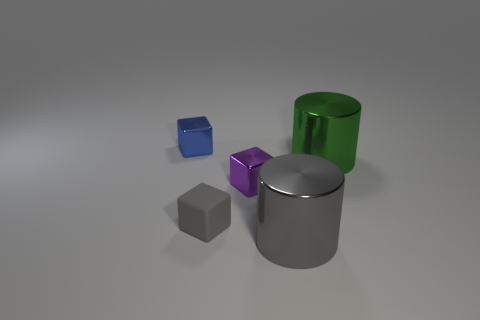Do the large metal thing in front of the small gray matte cube and the small block that is in front of the purple thing have the same color?
Offer a very short reply. Yes. There is another big object that is the same color as the matte thing; what shape is it?
Keep it short and to the point. Cylinder. There is a object that is behind the purple metal block and to the right of the blue shiny cube; what is its shape?
Keep it short and to the point. Cylinder. Is the number of small purple metallic things right of the green metallic thing the same as the number of brown blocks?
Give a very brief answer. Yes. How many objects are either small brown things or cylinders that are on the right side of the gray metallic cylinder?
Your answer should be compact. 1. Is there another purple object of the same shape as the purple thing?
Offer a terse response. No. Are there an equal number of small blue shiny cubes left of the tiny gray cube and metal objects on the right side of the big gray cylinder?
Your response must be concise. Yes. Is there any other thing that is the same size as the green cylinder?
Provide a succinct answer. Yes. How many red things are cylinders or shiny objects?
Your response must be concise. 0. How many yellow matte cylinders have the same size as the green shiny object?
Offer a terse response. 0. 